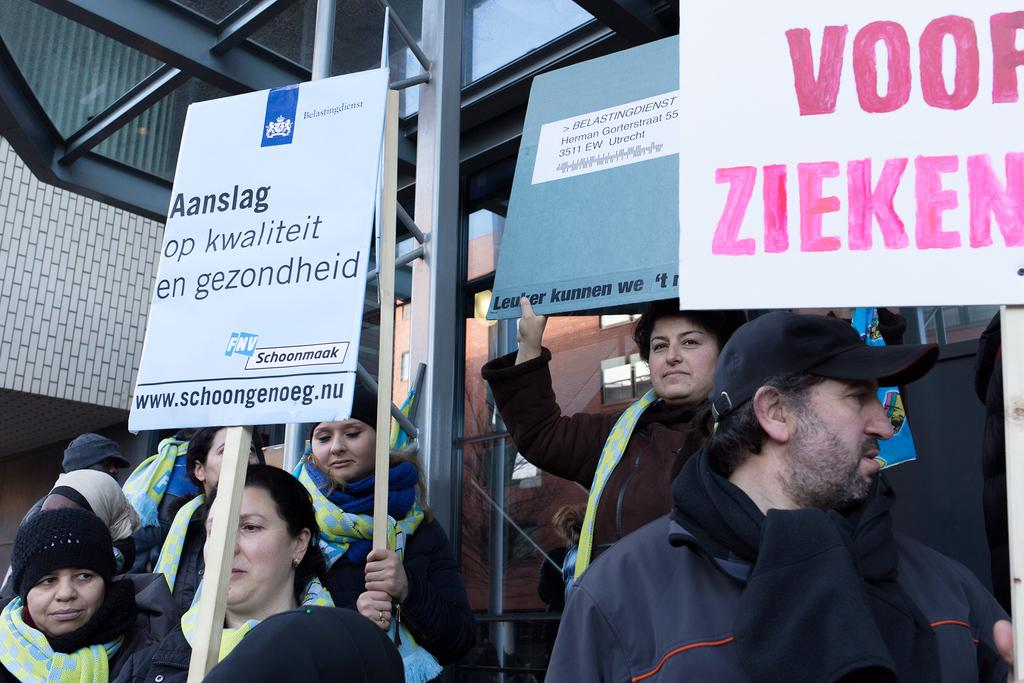What are the people in the foreground of the picture doing? The people are standing in the foreground of the picture and holding placards. What can be seen in the center of the image? There is an iron pole in the center of the image. What is visible in the background of the image? There are buildings and windows visible in the background of the image. What type of milk is being poured from the iron pole in the image? There is no milk or pouring action depicted in the image; it features people holding placards and an iron pole. What historical event is being commemorated by the people holding placards in the image? There is no indication of a specific historical event in the image; it only shows people holding placards and an iron pole. 